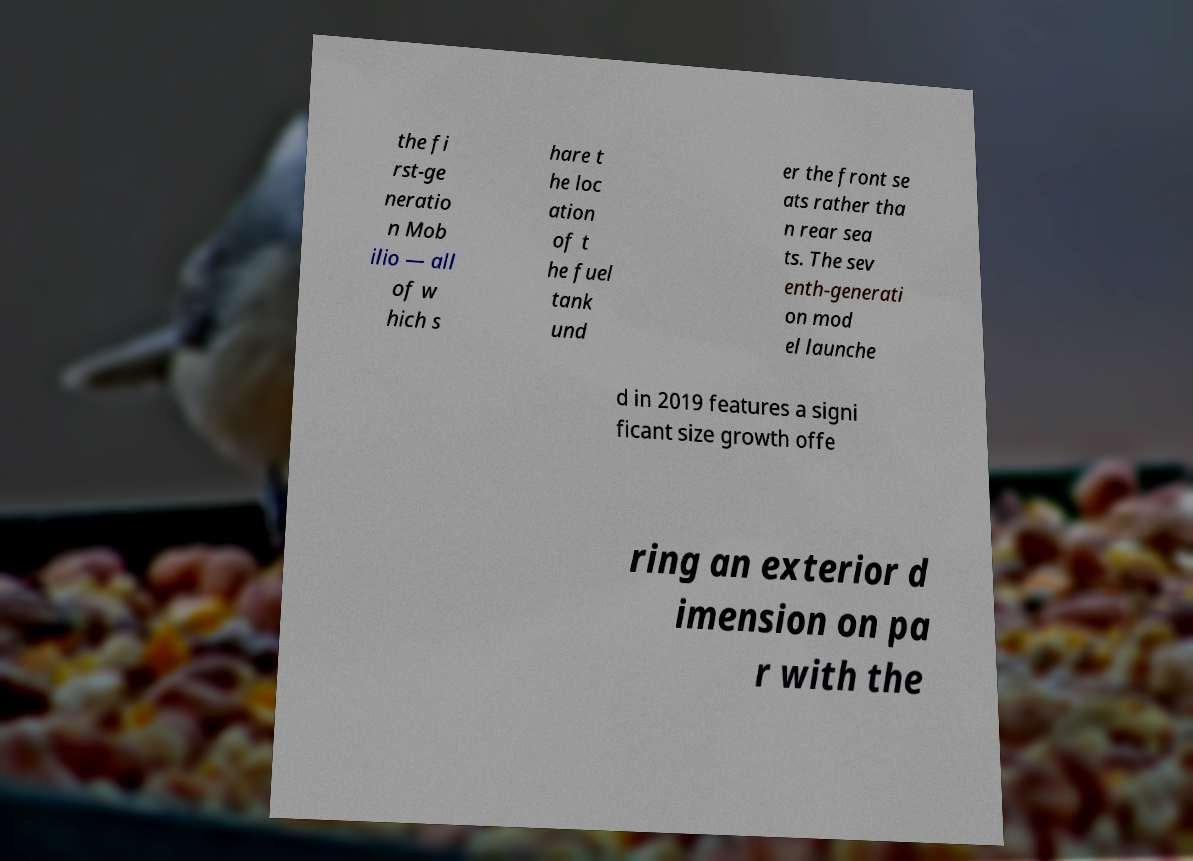There's text embedded in this image that I need extracted. Can you transcribe it verbatim? the fi rst-ge neratio n Mob ilio — all of w hich s hare t he loc ation of t he fuel tank und er the front se ats rather tha n rear sea ts. The sev enth-generati on mod el launche d in 2019 features a signi ficant size growth offe ring an exterior d imension on pa r with the 